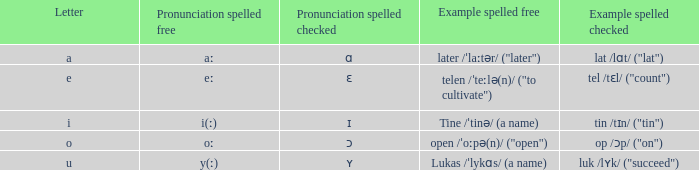Would you mind parsing the complete table? {'header': ['Letter', 'Pronunciation spelled free', 'Pronunciation spelled checked', 'Example spelled free', 'Example spelled checked'], 'rows': [['a', 'aː', 'ɑ', 'later /ˈlaːtər/ ("later")', 'lat /lɑt/ ("lat")'], ['e', 'eː', 'ɛ', 'telen /ˈteːlə(n)/ ("to cultivate")', 'tel /tɛl/ ("count")'], ['i', 'i(ː)', 'ɪ', 'Tine /ˈtinə/ (a name)', 'tin /tɪn/ ("tin")'], ['o', 'oː', 'ɔ', 'open /ˈoːpə(n)/ ("open")', 'op /ɔp/ ("on")'], ['u', 'y(ː)', 'ʏ', 'Lukas /ˈlykɑs/ (a name)', 'luk /lʏk/ ("succeed")']]} What is Pronunciation Spelled Free, when Pronunciation Spelled Checked is "ʏ"? Y(ː). 